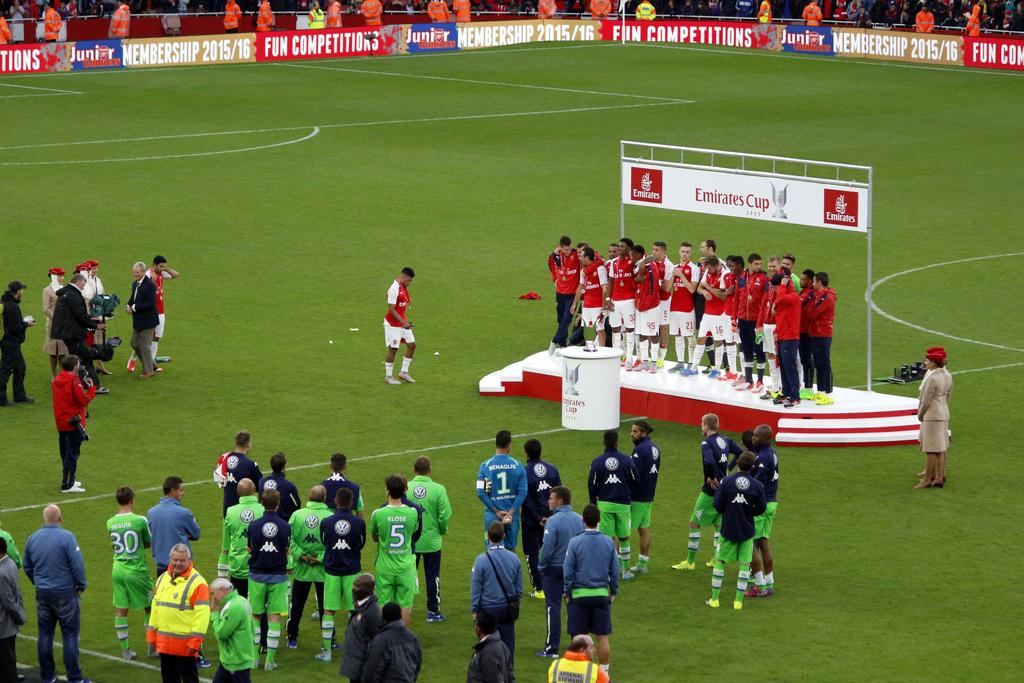<image>
Relay a brief, clear account of the picture shown. The victorious team at the Emirates Cup stands on the podium. 